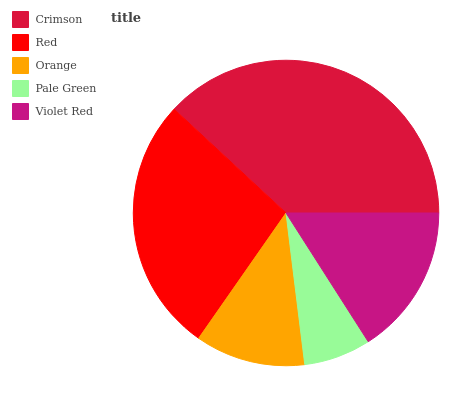Is Pale Green the minimum?
Answer yes or no. Yes. Is Crimson the maximum?
Answer yes or no. Yes. Is Red the minimum?
Answer yes or no. No. Is Red the maximum?
Answer yes or no. No. Is Crimson greater than Red?
Answer yes or no. Yes. Is Red less than Crimson?
Answer yes or no. Yes. Is Red greater than Crimson?
Answer yes or no. No. Is Crimson less than Red?
Answer yes or no. No. Is Violet Red the high median?
Answer yes or no. Yes. Is Violet Red the low median?
Answer yes or no. Yes. Is Crimson the high median?
Answer yes or no. No. Is Crimson the low median?
Answer yes or no. No. 